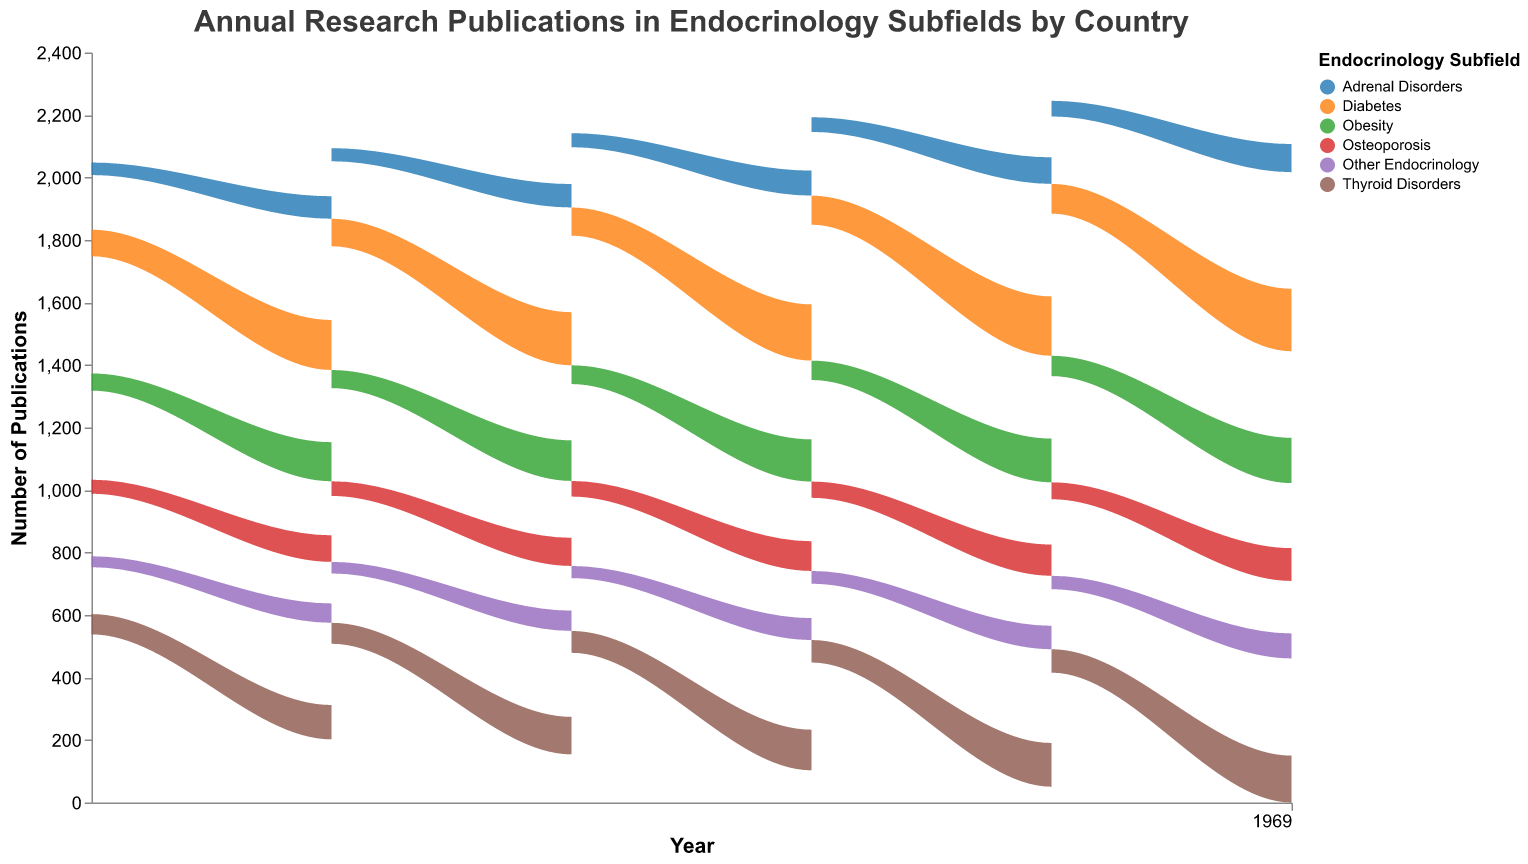What year had the highest number of diabetes research publications for the USA? The USA had the highest number of diabetes research publications in the year 2020 according to the figure.
Answer: 2020 Which country had the lowest number of obesity research publications in 2019? By examining the figure for the year 2019, Canada had the lowest number of obesity research publications.
Answer: Canada Out of thyroid disorders and adrenal disorders, which subfield had more publications in Japan in 2018? In 2018, the number of publications for thyroid disorders in Japan was 72, and for adrenal disorders, it was 47. Thus, thyroid disorders had more publications.
Answer: Thyroid Disorders How did the number of osteoporosis publications in Germany change from 2015 to 2018? The number of osteoporosis publications in Germany in 2015 was 50, and it increased to 58 in 2018. Thus, there was an increase of 8 publications.
Answer: Increased by 8 What's the total number of endocrinology publications (adding all subfields) in the UK for the year 2017? Adding the publications for diabetes (80), thyroid disorders (65), obesity (55), osteoporosis (43), adrenal disorders (38), and other endocrinology (34) in the UK for 2017 gives a total of 315 publications.
Answer: 315 What's the trend of diabetes research publications in the USA from 2015 to 2020? The number of diabetes research publications in the USA increased every year from 2015 (150) to 2020 (200). This shows a consistent upward trend.
Answer: Increasing trend Which country showed the highest growth in thyroid disorder publications from 2015 to 2020? By comparing the numbers from 2015 to 2020 for all countries, the USA showed the highest growth in thyroid disorder publications, increasing from 100 to 150.
Answer: USA How does the number of obesity publications in Canada in 2015 compare to that in 2020? In 2015, Canada had 45 obesity publications, and in 2020, the number increased to 57. Therefore, Canada had 12 more obesity publications in 2020 than in 2015.
Answer: Increased by 12 Which subfield had the least variation in publications in Germany from 2015 to 2020? By examining the publications in Germany across the years, other endocrinology shows the least variation, ranging from 40 (2015) to 52 (2020), a difference of 12.
Answer: Other Endocrinology For each country, name the subfield with the highest number of publications in 2020. By inspecting the figure for the year 2020:
- USA: Diabetes
- UK: Diabetes
- Canada: Diabetes
- Germany: Diabetes
- Japan: Diabetes
Answer: Diabetes (for all countries) 